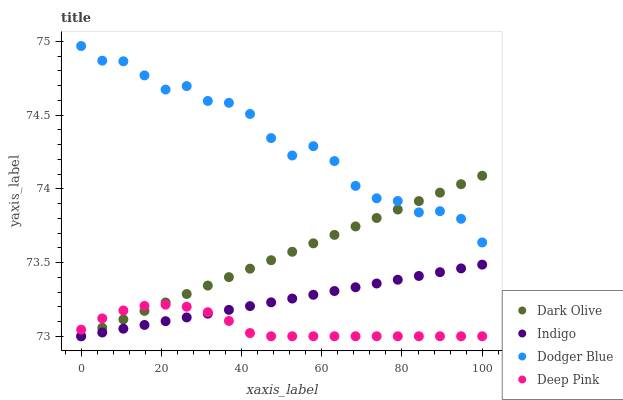Does Deep Pink have the minimum area under the curve?
Answer yes or no. Yes. Does Dodger Blue have the maximum area under the curve?
Answer yes or no. Yes. Does Dark Olive have the minimum area under the curve?
Answer yes or no. No. Does Dark Olive have the maximum area under the curve?
Answer yes or no. No. Is Indigo the smoothest?
Answer yes or no. Yes. Is Dodger Blue the roughest?
Answer yes or no. Yes. Is Dark Olive the smoothest?
Answer yes or no. No. Is Dark Olive the roughest?
Answer yes or no. No. Does Dark Olive have the lowest value?
Answer yes or no. Yes. Does Dodger Blue have the highest value?
Answer yes or no. Yes. Does Dark Olive have the highest value?
Answer yes or no. No. Is Indigo less than Dodger Blue?
Answer yes or no. Yes. Is Dodger Blue greater than Indigo?
Answer yes or no. Yes. Does Deep Pink intersect Indigo?
Answer yes or no. Yes. Is Deep Pink less than Indigo?
Answer yes or no. No. Is Deep Pink greater than Indigo?
Answer yes or no. No. Does Indigo intersect Dodger Blue?
Answer yes or no. No. 